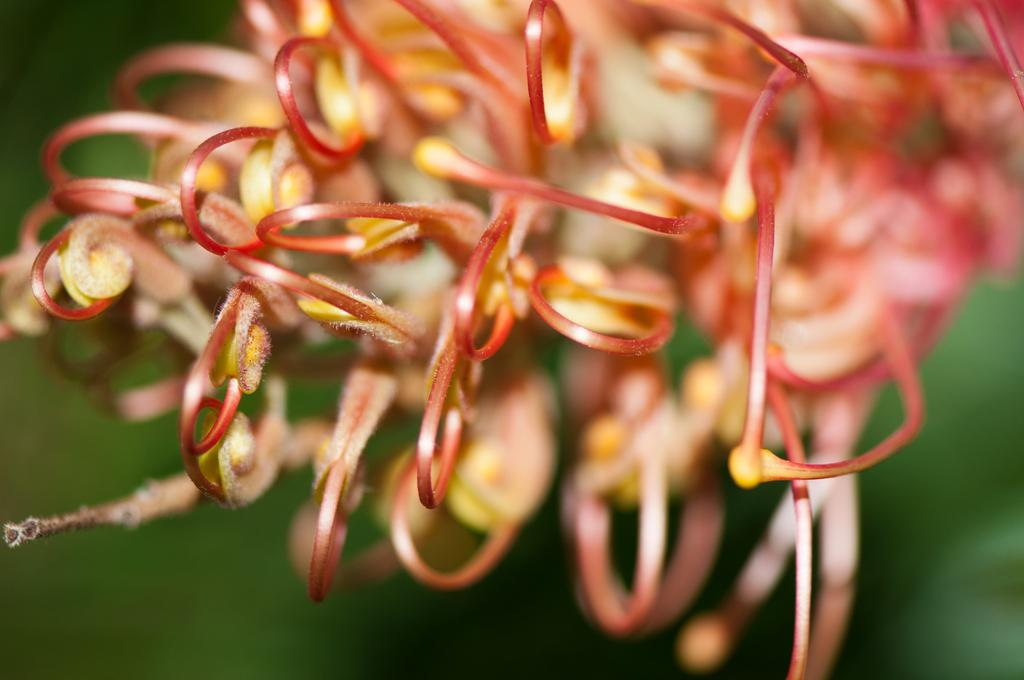What objects in the image resemble flowers? There are objects in the foreground of the image that resemble flowers. What is the color of the background in the image? The background of the image is green in color. How do the dinosaurs control the green background in the image? There are no dinosaurs present in the image, so they cannot control the green background. 